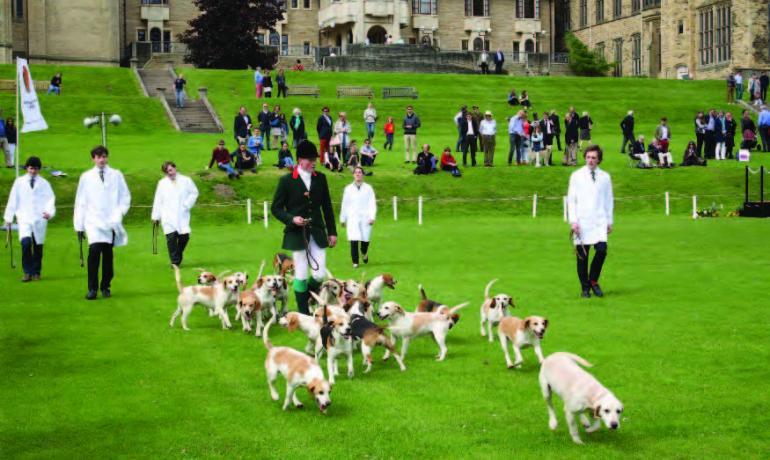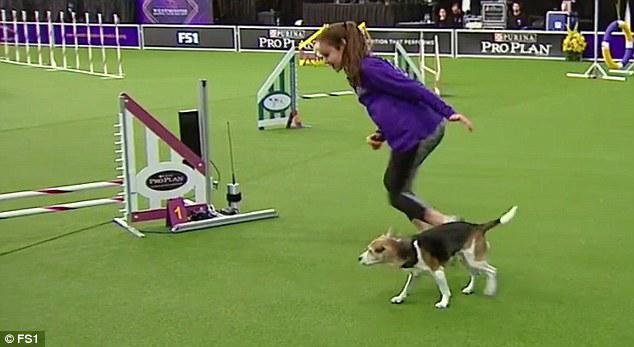The first image is the image on the left, the second image is the image on the right. For the images shown, is this caption "One image contains a single Beagle and a girl in a purple shirt on an agility course." true? Answer yes or no. Yes. 